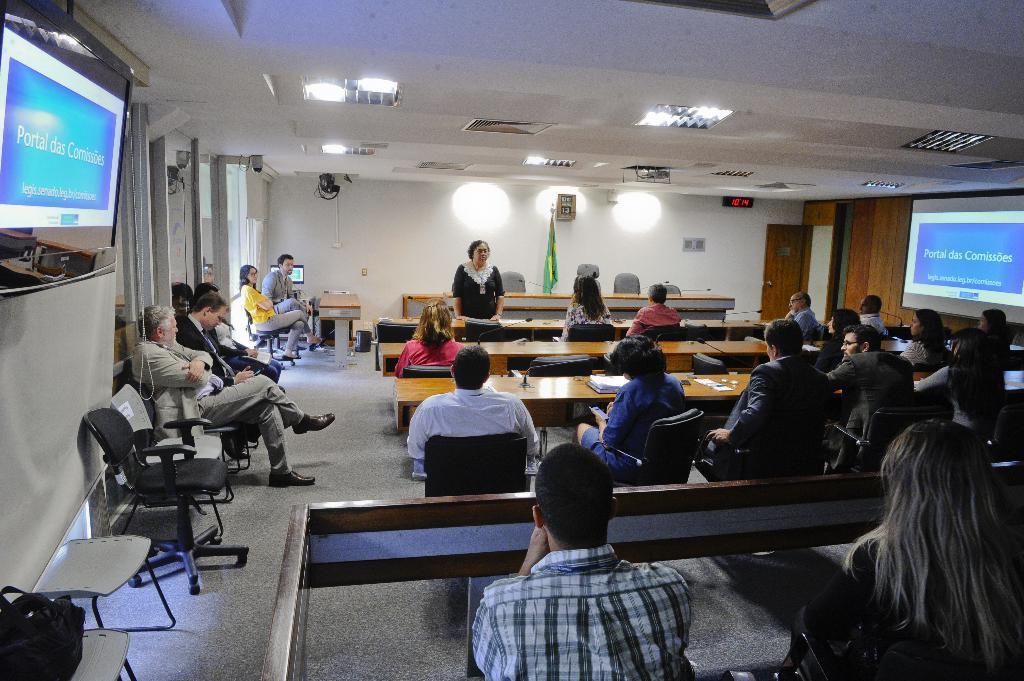Can you describe this image briefly? This picture shows a woman standing and speaking and we see a flag on the back and few roof lights and we see all the people seated on the chairs and we see a television on the left and a projector screen on the right and we see a projector to the roof and we see a bag on the chair. 